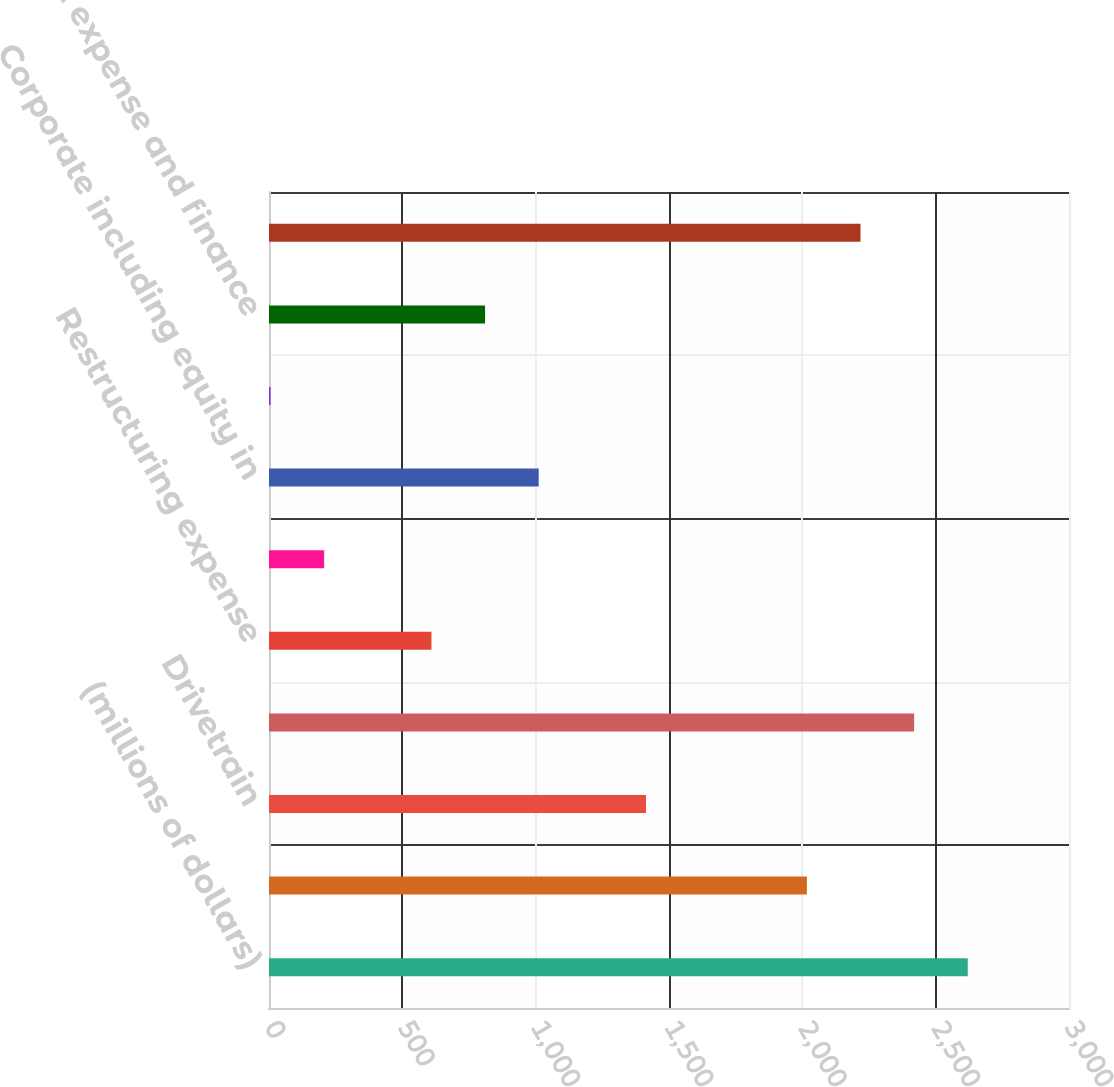Convert chart to OTSL. <chart><loc_0><loc_0><loc_500><loc_500><bar_chart><fcel>(millions of dollars)<fcel>Engine<fcel>Drivetrain<fcel>Adjusted EBIT<fcel>Restructuring expense<fcel>Merger and acquisition expense<fcel>Corporate including equity in<fcel>Interest income<fcel>Interest expense and finance<fcel>Earnings before income taxes<nl><fcel>2620.36<fcel>2017<fcel>1413.64<fcel>2419.24<fcel>609.16<fcel>206.92<fcel>1011.4<fcel>5.8<fcel>810.28<fcel>2218.12<nl></chart> 